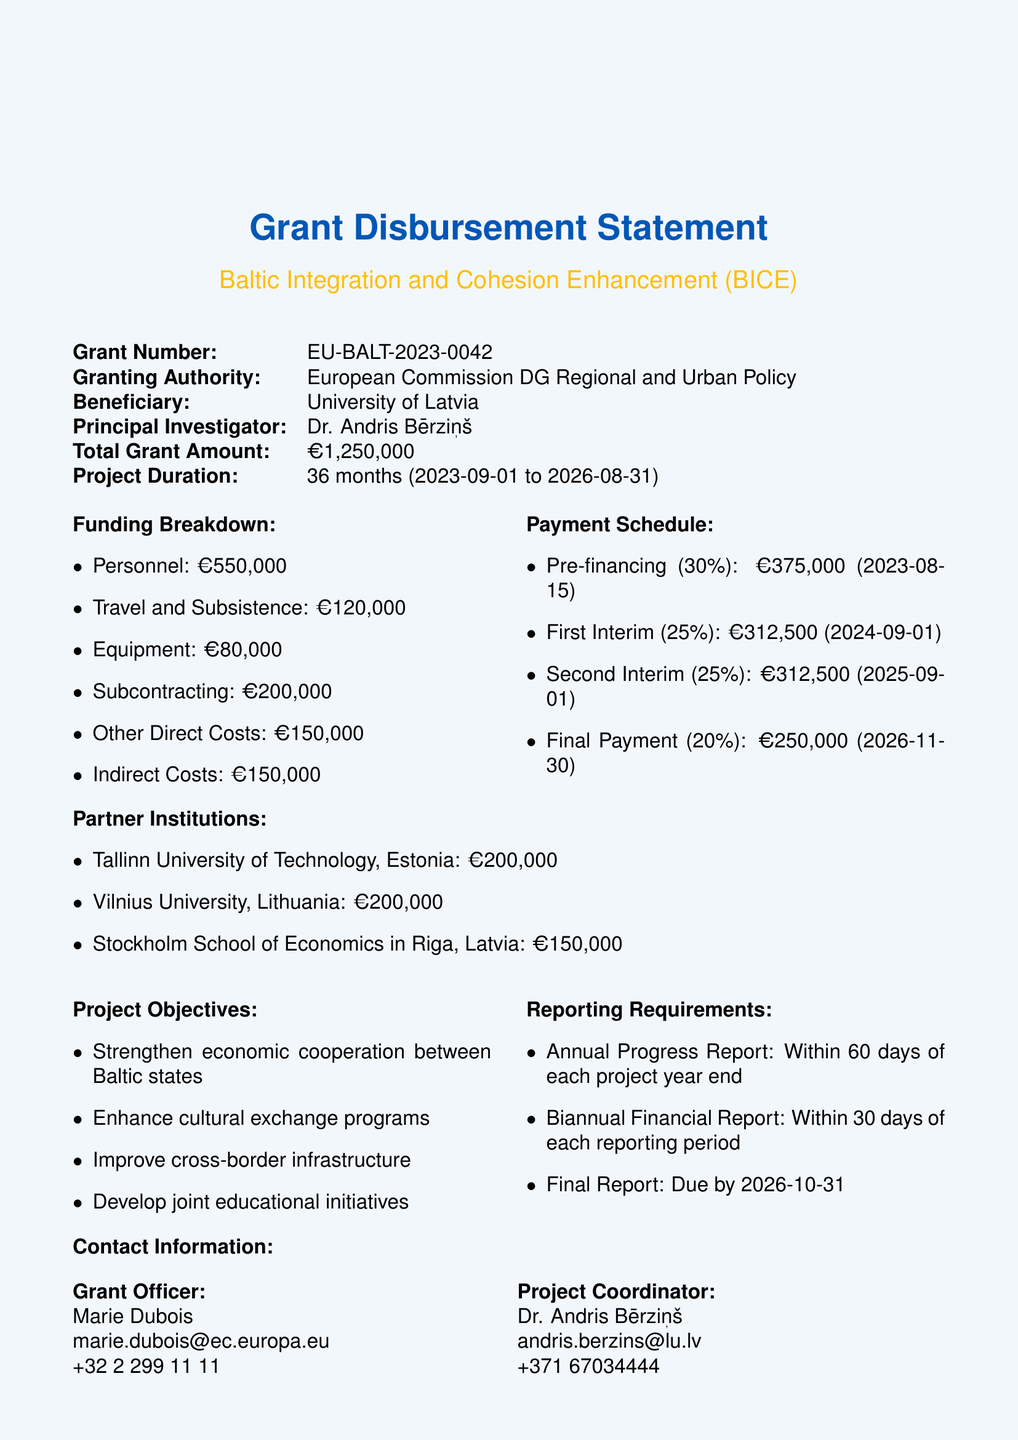What is the total grant amount? The total grant amount is mentioned in the document as a specific figure allocated for the project.
Answer: €1,250,000 Who is the principal investigator? The principal investigator is responsible for the execution of the project, and their name is provided in the document.
Answer: Dr. Andris Bērziņš What is the duration of the project? The project duration is specified in terms of months and start and end dates in the document.
Answer: 36 months When is the final payment due? The final payment date is part of the payment schedule that outlines when funds are to be disbursed.
Answer: 2026-11-30 How much is allocated for travel and subsistence? This amount is listed under the funding breakdown, detailing how the total grant is allocated among different categories.
Answer: €120,000 What are the project objectives? The project objectives are a set of goals listed in the document, aimed at enhancing Baltic integration.
Answer: Strengthen economic cooperation between Baltic states, Enhance cultural exchange programs, Improve cross-border infrastructure, Develop joint educational initiatives How many interim payments are scheduled? The number of interim payments is part of the payment schedule detailing the installments identified in the document.
Answer: Two What is the allocated fund for Vilnius University? The document specifies allocated funds for each partner institution involved in the project.
Answer: €200,000 